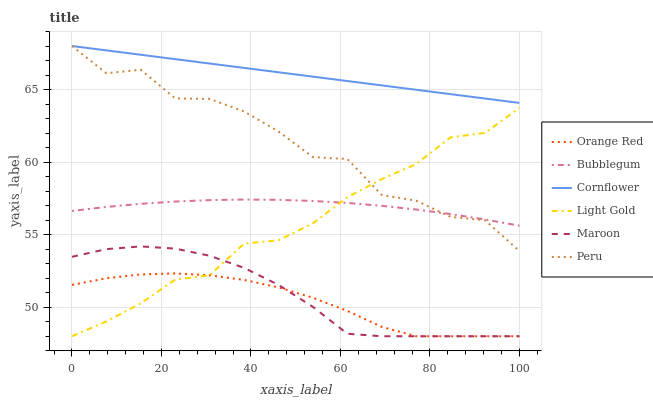Does Orange Red have the minimum area under the curve?
Answer yes or no. Yes. Does Cornflower have the maximum area under the curve?
Answer yes or no. Yes. Does Maroon have the minimum area under the curve?
Answer yes or no. No. Does Maroon have the maximum area under the curve?
Answer yes or no. No. Is Cornflower the smoothest?
Answer yes or no. Yes. Is Peru the roughest?
Answer yes or no. Yes. Is Maroon the smoothest?
Answer yes or no. No. Is Maroon the roughest?
Answer yes or no. No. Does Maroon have the lowest value?
Answer yes or no. Yes. Does Bubblegum have the lowest value?
Answer yes or no. No. Does Peru have the highest value?
Answer yes or no. Yes. Does Maroon have the highest value?
Answer yes or no. No. Is Light Gold less than Cornflower?
Answer yes or no. Yes. Is Cornflower greater than Maroon?
Answer yes or no. Yes. Does Light Gold intersect Peru?
Answer yes or no. Yes. Is Light Gold less than Peru?
Answer yes or no. No. Is Light Gold greater than Peru?
Answer yes or no. No. Does Light Gold intersect Cornflower?
Answer yes or no. No. 